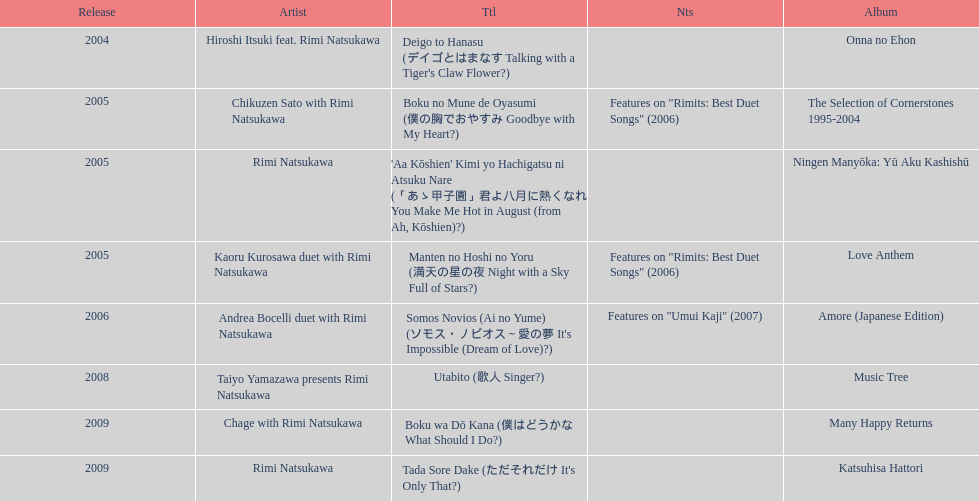Which title has the same notes as night with a sky full of stars? Boku no Mune de Oyasumi (僕の胸でおやすみ Goodbye with My Heart?). 